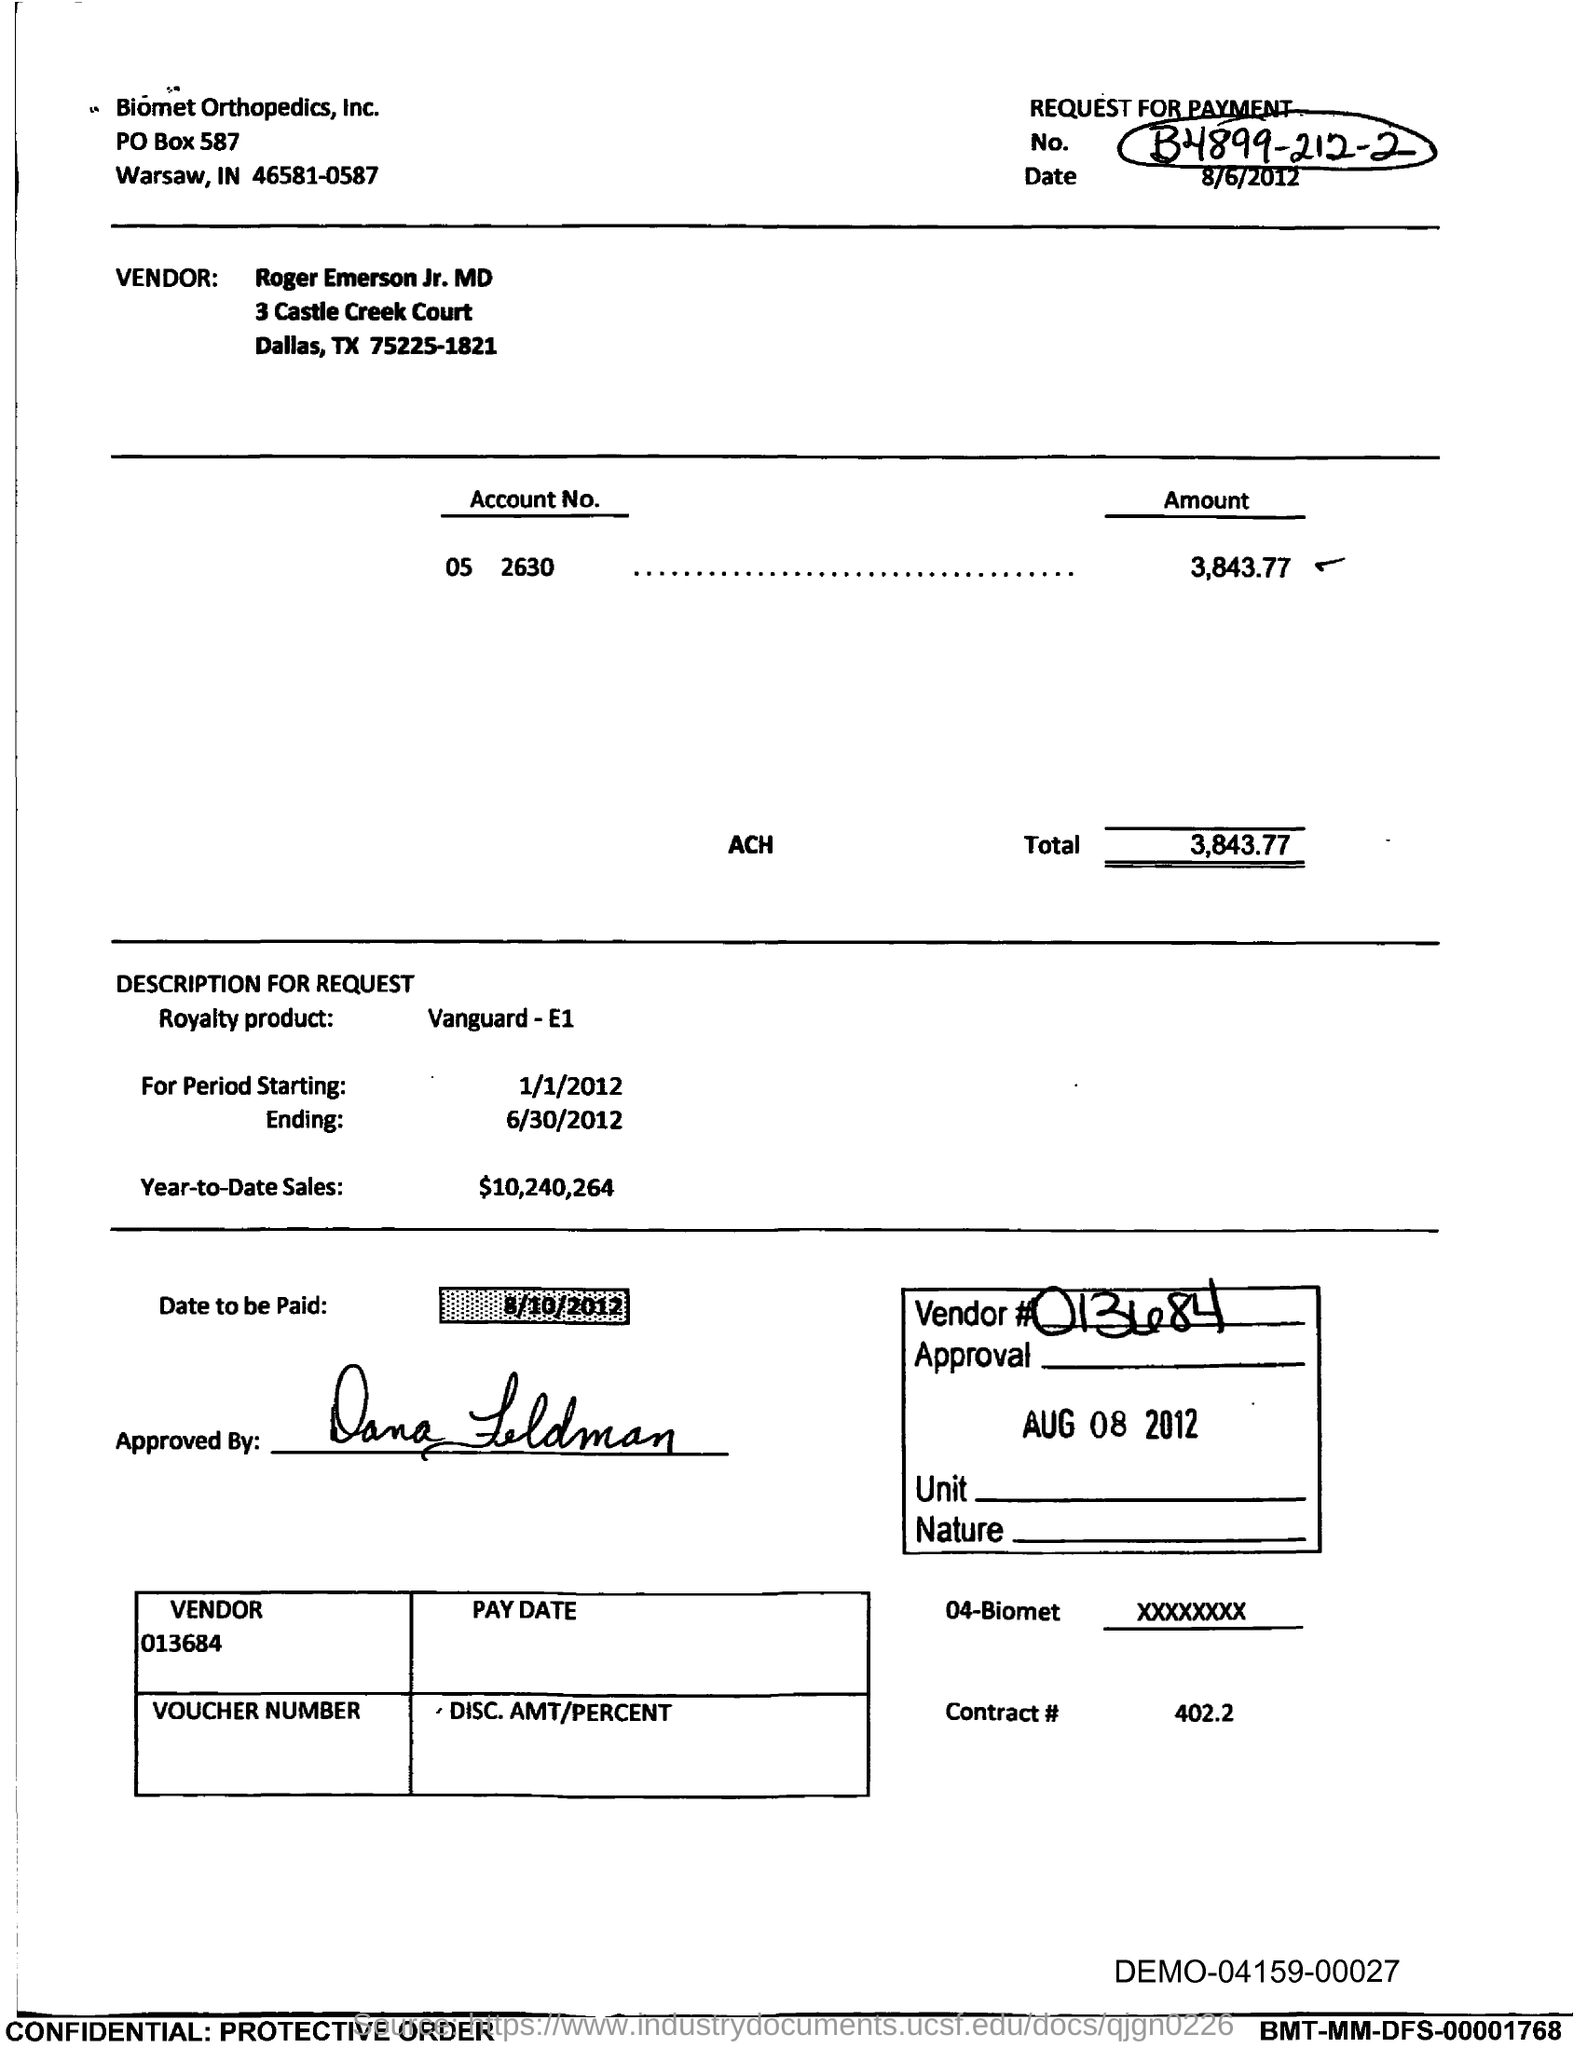Identify some key points in this picture. The amount for account number 05 2630 is 3,843.77. Year-to-date sales for the current time period have reached a value of 10,240,264. The total amount given in this document is 3,843.77. The period starting date in this document is January 1st, 2012. The date of this document is August 6, 2012. 